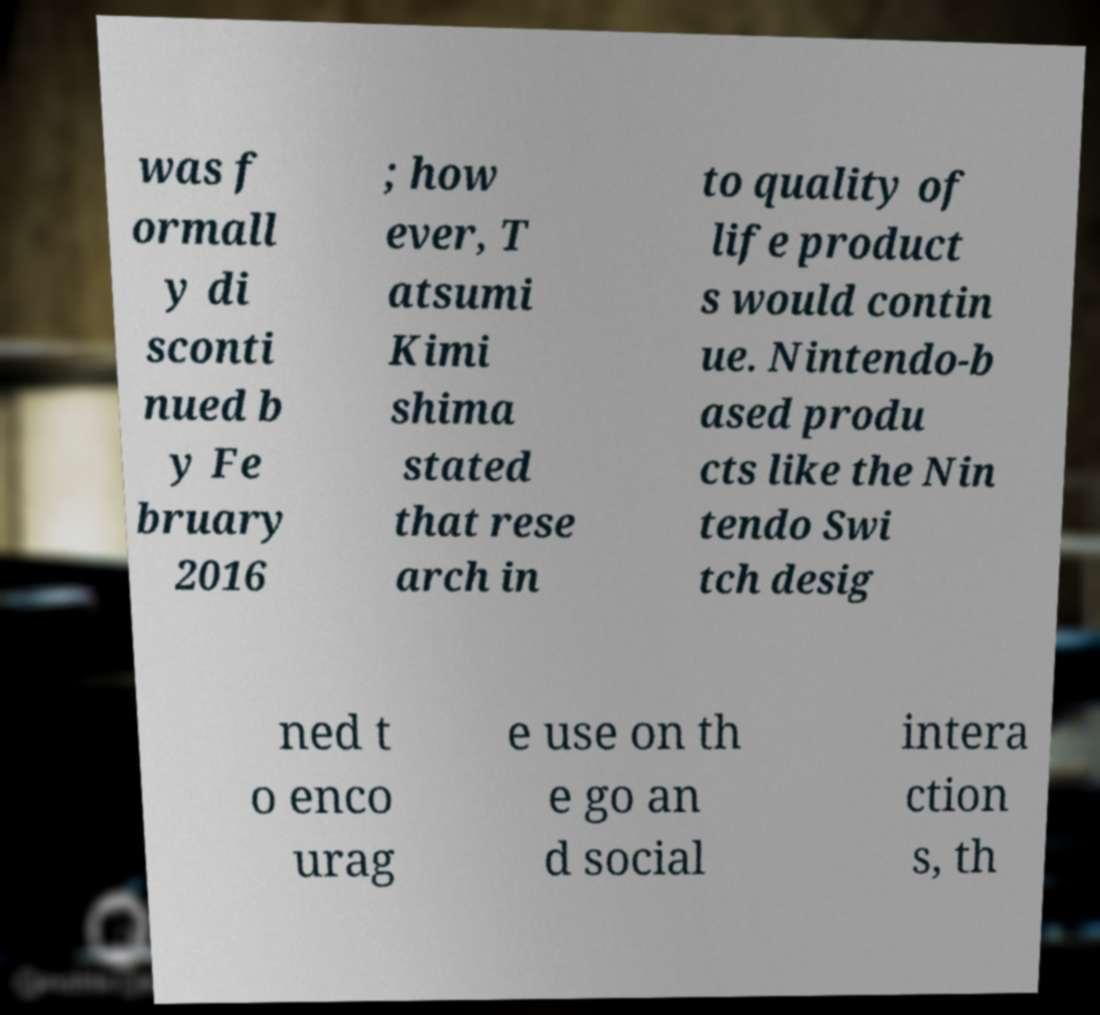What messages or text are displayed in this image? I need them in a readable, typed format. was f ormall y di sconti nued b y Fe bruary 2016 ; how ever, T atsumi Kimi shima stated that rese arch in to quality of life product s would contin ue. Nintendo-b ased produ cts like the Nin tendo Swi tch desig ned t o enco urag e use on th e go an d social intera ction s, th 